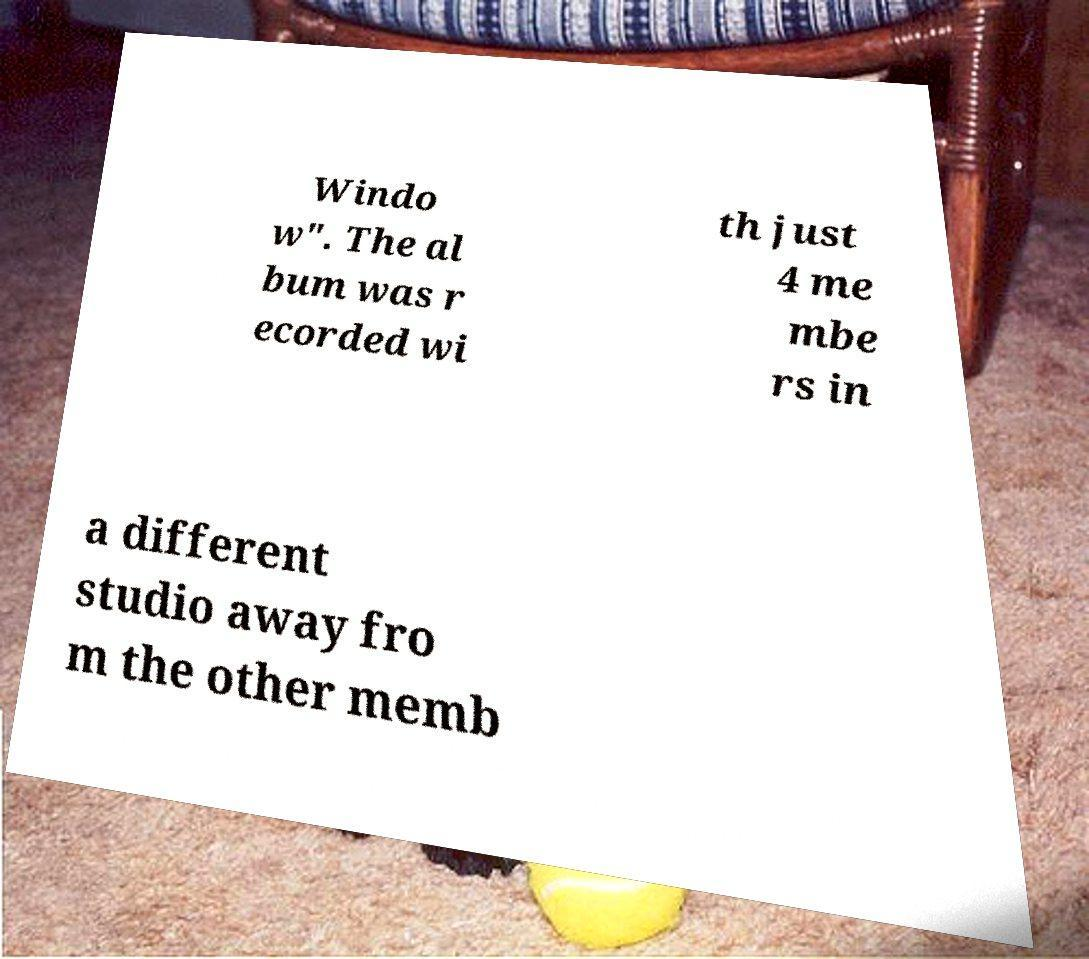Could you extract and type out the text from this image? Windo w". The al bum was r ecorded wi th just 4 me mbe rs in a different studio away fro m the other memb 